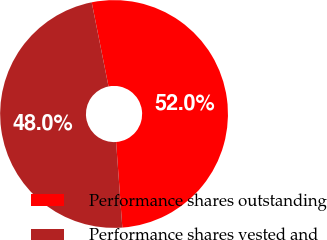Convert chart to OTSL. <chart><loc_0><loc_0><loc_500><loc_500><pie_chart><fcel>Performance shares outstanding<fcel>Performance shares vested and<nl><fcel>51.98%<fcel>48.02%<nl></chart> 